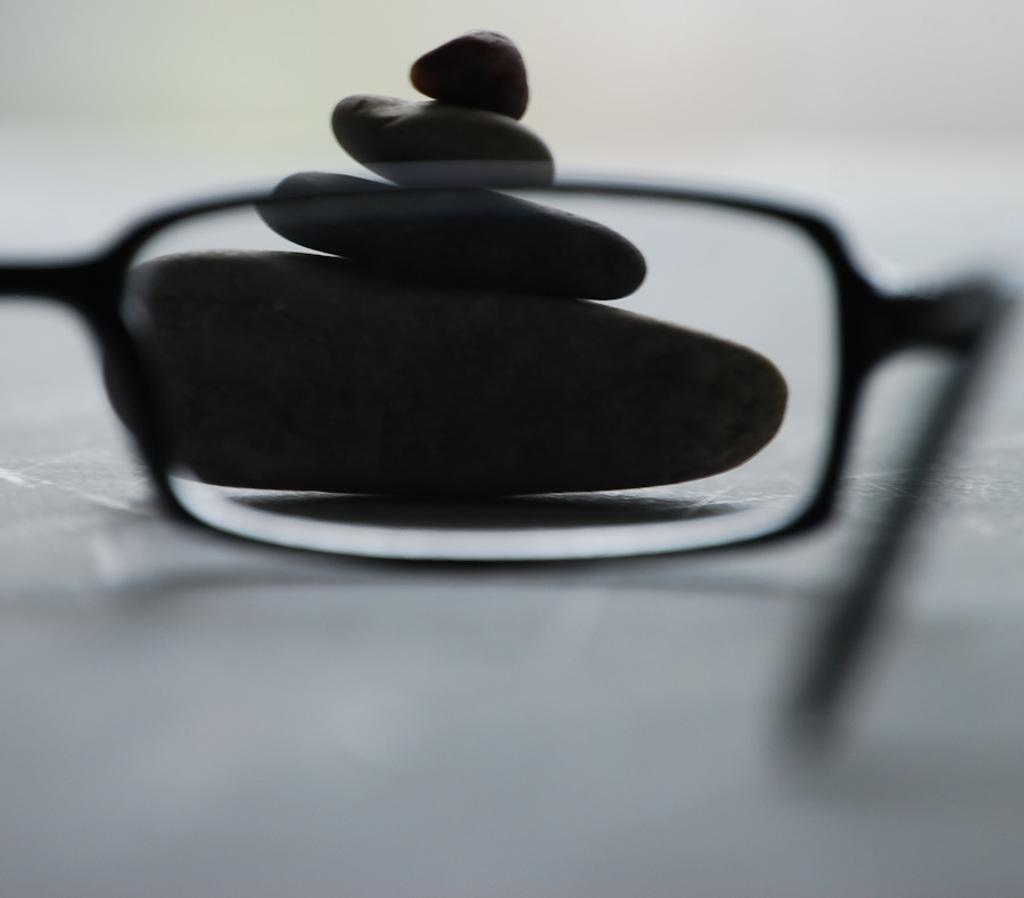What type of object can be seen in the image related to vision? There are spectacles in the image. What type of natural objects can be seen in the image? There are stones in the image. What type of pen is being used to write on the stones in the image? There is no pen or writing present on the stones in the image. What invention is being demonstrated in the image? There is no specific invention being demonstrated in the image; it only features spectacles and stones. 